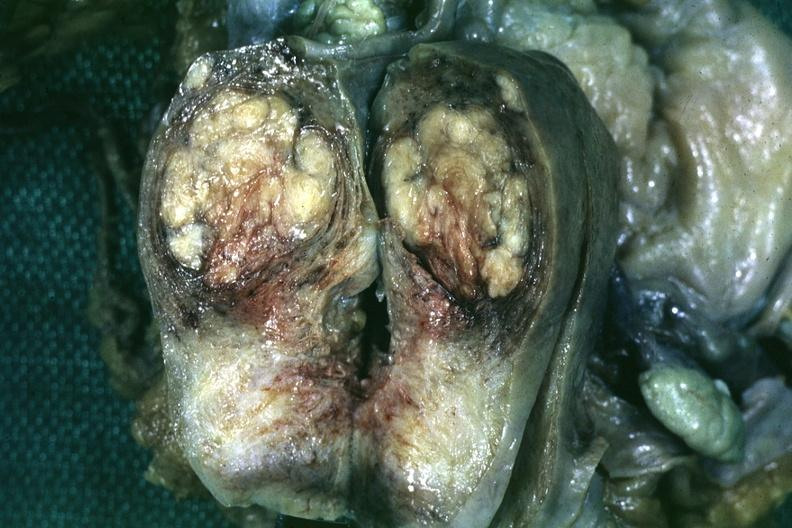s this myoma present?
Answer the question using a single word or phrase. No 